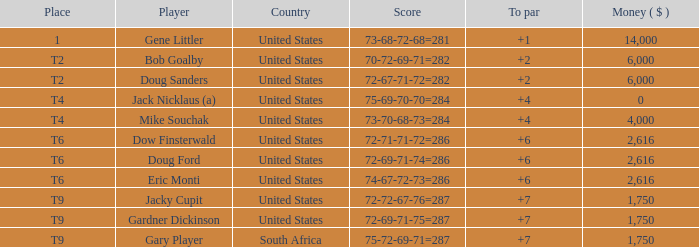I'm looking to parse the entire table for insights. Could you assist me with that? {'header': ['Place', 'Player', 'Country', 'Score', 'To par', 'Money ( $ )'], 'rows': [['1', 'Gene Littler', 'United States', '73-68-72-68=281', '+1', '14,000'], ['T2', 'Bob Goalby', 'United States', '70-72-69-71=282', '+2', '6,000'], ['T2', 'Doug Sanders', 'United States', '72-67-71-72=282', '+2', '6,000'], ['T4', 'Jack Nicklaus (a)', 'United States', '75-69-70-70=284', '+4', '0'], ['T4', 'Mike Souchak', 'United States', '73-70-68-73=284', '+4', '4,000'], ['T6', 'Dow Finsterwald', 'United States', '72-71-71-72=286', '+6', '2,616'], ['T6', 'Doug Ford', 'United States', '72-69-71-74=286', '+6', '2,616'], ['T6', 'Eric Monti', 'United States', '74-67-72-73=286', '+6', '2,616'], ['T9', 'Jacky Cupit', 'United States', '72-72-67-76=287', '+7', '1,750'], ['T9', 'Gardner Dickinson', 'United States', '72-69-71-75=287', '+7', '1,750'], ['T9', 'Gary Player', 'South Africa', '75-72-69-71=287', '+7', '1,750']]} What is the average To Par, when Score is "72-67-71-72=282"? 2.0. 